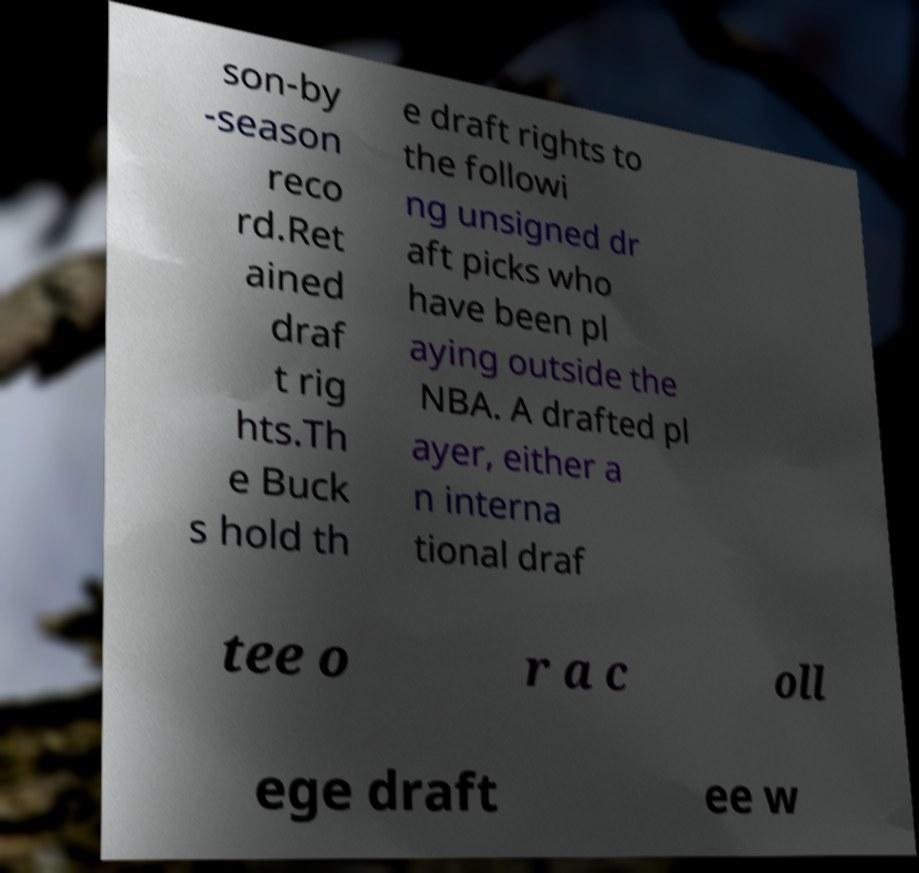I need the written content from this picture converted into text. Can you do that? son-by -season reco rd.Ret ained draf t rig hts.Th e Buck s hold th e draft rights to the followi ng unsigned dr aft picks who have been pl aying outside the NBA. A drafted pl ayer, either a n interna tional draf tee o r a c oll ege draft ee w 